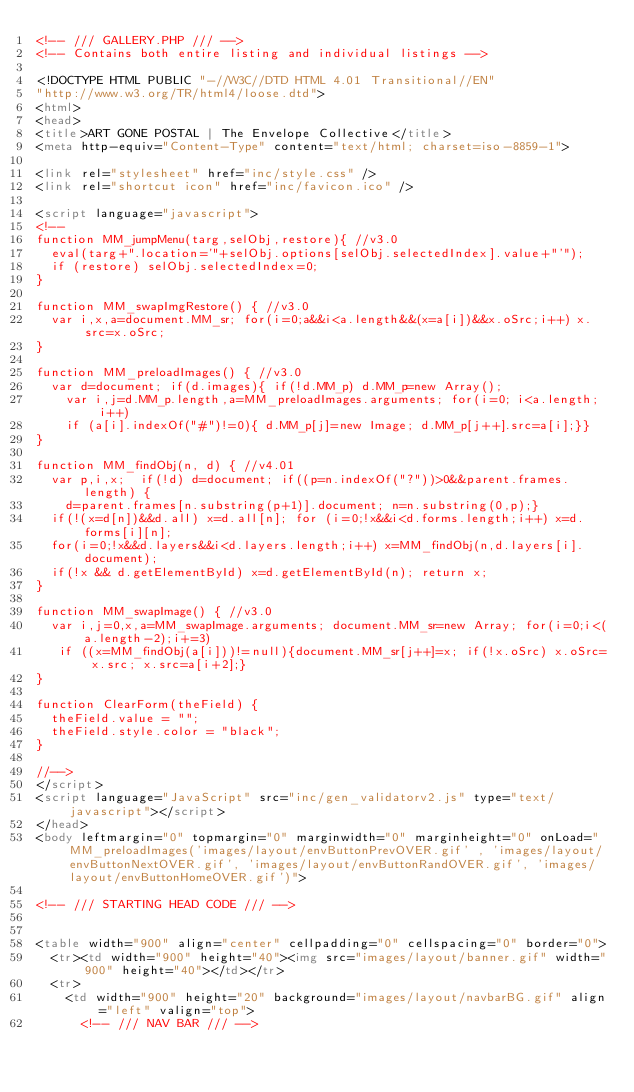Convert code to text. <code><loc_0><loc_0><loc_500><loc_500><_HTML_><!-- /// GALLERY.PHP /// -->
<!-- Contains both entire listing and individual listings -->

<!DOCTYPE HTML PUBLIC "-//W3C//DTD HTML 4.01 Transitional//EN"
"http://www.w3.org/TR/html4/loose.dtd">
<html>
<head>
<title>ART GONE POSTAL | The Envelope Collective</title>
<meta http-equiv="Content-Type" content="text/html; charset=iso-8859-1">

<link rel="stylesheet" href="inc/style.css" />
<link rel="shortcut icon" href="inc/favicon.ico" />

<script language="javascript">
<!--
function MM_jumpMenu(targ,selObj,restore){ //v3.0
  eval(targ+".location='"+selObj.options[selObj.selectedIndex].value+"'");
  if (restore) selObj.selectedIndex=0;
}

function MM_swapImgRestore() { //v3.0
  var i,x,a=document.MM_sr; for(i=0;a&&i<a.length&&(x=a[i])&&x.oSrc;i++) x.src=x.oSrc;
}

function MM_preloadImages() { //v3.0
  var d=document; if(d.images){ if(!d.MM_p) d.MM_p=new Array();
    var i,j=d.MM_p.length,a=MM_preloadImages.arguments; for(i=0; i<a.length; i++)
    if (a[i].indexOf("#")!=0){ d.MM_p[j]=new Image; d.MM_p[j++].src=a[i];}}
}

function MM_findObj(n, d) { //v4.01
  var p,i,x;  if(!d) d=document; if((p=n.indexOf("?"))>0&&parent.frames.length) {
    d=parent.frames[n.substring(p+1)].document; n=n.substring(0,p);}
  if(!(x=d[n])&&d.all) x=d.all[n]; for (i=0;!x&&i<d.forms.length;i++) x=d.forms[i][n];
  for(i=0;!x&&d.layers&&i<d.layers.length;i++) x=MM_findObj(n,d.layers[i].document);
  if(!x && d.getElementById) x=d.getElementById(n); return x;
}

function MM_swapImage() { //v3.0
  var i,j=0,x,a=MM_swapImage.arguments; document.MM_sr=new Array; for(i=0;i<(a.length-2);i+=3)
   if ((x=MM_findObj(a[i]))!=null){document.MM_sr[j++]=x; if(!x.oSrc) x.oSrc=x.src; x.src=a[i+2];}
}

function ClearForm(theField) {
  theField.value = "";
  theField.style.color = "black";
}

//-->
</script>
<script language="JavaScript" src="inc/gen_validatorv2.js" type="text/javascript"></script>
</head>
<body leftmargin="0" topmargin="0" marginwidth="0" marginheight="0" onLoad="MM_preloadImages('images/layout/envButtonPrevOVER.gif' , 'images/layout/envButtonNextOVER.gif', 'images/layout/envButtonRandOVER.gif', 'images/layout/envButtonHomeOVER.gif')">

<!-- /// STARTING HEAD CODE /// -->


<table width="900" align="center" cellpadding="0" cellspacing="0" border="0">
	<tr><td width="900" height="40"><img src="images/layout/banner.gif" width="900" height="40"></td></tr>
	<tr>
		<td width="900" height="20" background="images/layout/navbarBG.gif" align="left" valign="top">
			<!-- /// NAV BAR /// --></code> 